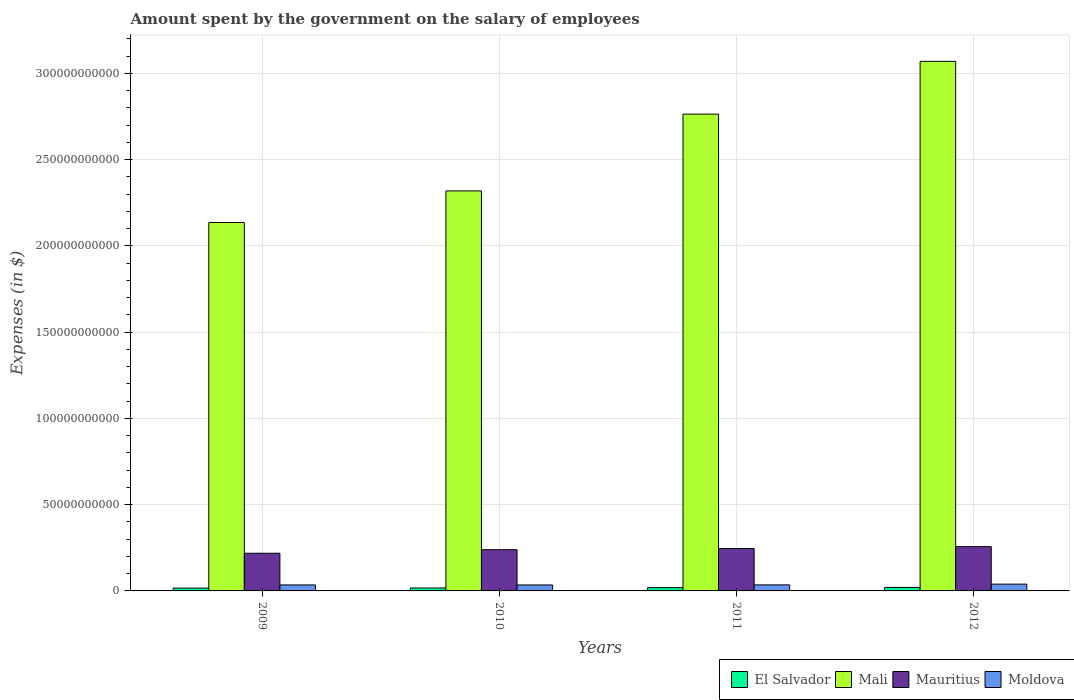How many groups of bars are there?
Keep it short and to the point. 4. Are the number of bars per tick equal to the number of legend labels?
Ensure brevity in your answer.  Yes. How many bars are there on the 1st tick from the left?
Offer a very short reply. 4. What is the label of the 4th group of bars from the left?
Your response must be concise. 2012. What is the amount spent on the salary of employees by the government in Moldova in 2011?
Ensure brevity in your answer.  3.50e+09. Across all years, what is the maximum amount spent on the salary of employees by the government in El Salvador?
Make the answer very short. 2.02e+09. Across all years, what is the minimum amount spent on the salary of employees by the government in El Salvador?
Your response must be concise. 1.64e+09. In which year was the amount spent on the salary of employees by the government in Moldova maximum?
Ensure brevity in your answer.  2012. In which year was the amount spent on the salary of employees by the government in El Salvador minimum?
Provide a short and direct response. 2009. What is the total amount spent on the salary of employees by the government in Mauritius in the graph?
Offer a very short reply. 9.60e+1. What is the difference between the amount spent on the salary of employees by the government in Mauritius in 2010 and that in 2012?
Give a very brief answer. -1.77e+09. What is the difference between the amount spent on the salary of employees by the government in El Salvador in 2010 and the amount spent on the salary of employees by the government in Moldova in 2012?
Offer a very short reply. -2.24e+09. What is the average amount spent on the salary of employees by the government in Moldova per year?
Provide a succinct answer. 3.59e+09. In the year 2011, what is the difference between the amount spent on the salary of employees by the government in El Salvador and amount spent on the salary of employees by the government in Mali?
Your response must be concise. -2.74e+11. In how many years, is the amount spent on the salary of employees by the government in Moldova greater than 300000000000 $?
Provide a short and direct response. 0. What is the ratio of the amount spent on the salary of employees by the government in Mauritius in 2009 to that in 2010?
Give a very brief answer. 0.91. What is the difference between the highest and the second highest amount spent on the salary of employees by the government in Mauritius?
Offer a terse response. 1.09e+09. What is the difference between the highest and the lowest amount spent on the salary of employees by the government in Mauritius?
Your answer should be compact. 3.83e+09. In how many years, is the amount spent on the salary of employees by the government in Moldova greater than the average amount spent on the salary of employees by the government in Moldova taken over all years?
Ensure brevity in your answer.  1. Is the sum of the amount spent on the salary of employees by the government in Mauritius in 2009 and 2010 greater than the maximum amount spent on the salary of employees by the government in El Salvador across all years?
Your response must be concise. Yes. What does the 2nd bar from the left in 2012 represents?
Your answer should be very brief. Mali. What does the 4th bar from the right in 2009 represents?
Provide a succinct answer. El Salvador. How many bars are there?
Offer a terse response. 16. How many years are there in the graph?
Offer a terse response. 4. Does the graph contain grids?
Offer a terse response. Yes. How many legend labels are there?
Your response must be concise. 4. What is the title of the graph?
Offer a very short reply. Amount spent by the government on the salary of employees. What is the label or title of the Y-axis?
Give a very brief answer. Expenses (in $). What is the Expenses (in $) of El Salvador in 2009?
Provide a succinct answer. 1.64e+09. What is the Expenses (in $) of Mali in 2009?
Ensure brevity in your answer.  2.14e+11. What is the Expenses (in $) of Mauritius in 2009?
Provide a short and direct response. 2.18e+1. What is the Expenses (in $) of Moldova in 2009?
Provide a succinct answer. 3.47e+09. What is the Expenses (in $) in El Salvador in 2010?
Keep it short and to the point. 1.70e+09. What is the Expenses (in $) of Mali in 2010?
Keep it short and to the point. 2.32e+11. What is the Expenses (in $) in Mauritius in 2010?
Provide a short and direct response. 2.39e+1. What is the Expenses (in $) of Moldova in 2010?
Offer a terse response. 3.46e+09. What is the Expenses (in $) in El Salvador in 2011?
Offer a terse response. 1.90e+09. What is the Expenses (in $) in Mali in 2011?
Give a very brief answer. 2.76e+11. What is the Expenses (in $) in Mauritius in 2011?
Offer a very short reply. 2.46e+1. What is the Expenses (in $) in Moldova in 2011?
Offer a terse response. 3.50e+09. What is the Expenses (in $) in El Salvador in 2012?
Your answer should be compact. 2.02e+09. What is the Expenses (in $) in Mali in 2012?
Make the answer very short. 3.07e+11. What is the Expenses (in $) in Mauritius in 2012?
Your response must be concise. 2.57e+1. What is the Expenses (in $) in Moldova in 2012?
Your answer should be very brief. 3.94e+09. Across all years, what is the maximum Expenses (in $) of El Salvador?
Ensure brevity in your answer.  2.02e+09. Across all years, what is the maximum Expenses (in $) in Mali?
Make the answer very short. 3.07e+11. Across all years, what is the maximum Expenses (in $) in Mauritius?
Give a very brief answer. 2.57e+1. Across all years, what is the maximum Expenses (in $) in Moldova?
Your answer should be very brief. 3.94e+09. Across all years, what is the minimum Expenses (in $) of El Salvador?
Keep it short and to the point. 1.64e+09. Across all years, what is the minimum Expenses (in $) in Mali?
Give a very brief answer. 2.14e+11. Across all years, what is the minimum Expenses (in $) of Mauritius?
Make the answer very short. 2.18e+1. Across all years, what is the minimum Expenses (in $) of Moldova?
Ensure brevity in your answer.  3.46e+09. What is the total Expenses (in $) of El Salvador in the graph?
Ensure brevity in your answer.  7.26e+09. What is the total Expenses (in $) of Mali in the graph?
Ensure brevity in your answer.  1.03e+12. What is the total Expenses (in $) in Mauritius in the graph?
Ensure brevity in your answer.  9.60e+1. What is the total Expenses (in $) in Moldova in the graph?
Provide a succinct answer. 1.44e+1. What is the difference between the Expenses (in $) of El Salvador in 2009 and that in 2010?
Your answer should be very brief. -6.58e+07. What is the difference between the Expenses (in $) in Mali in 2009 and that in 2010?
Your response must be concise. -1.83e+1. What is the difference between the Expenses (in $) of Mauritius in 2009 and that in 2010?
Offer a very short reply. -2.06e+09. What is the difference between the Expenses (in $) of Moldova in 2009 and that in 2010?
Make the answer very short. 1.01e+07. What is the difference between the Expenses (in $) in El Salvador in 2009 and that in 2011?
Provide a succinct answer. -2.57e+08. What is the difference between the Expenses (in $) of Mali in 2009 and that in 2011?
Your answer should be compact. -6.28e+1. What is the difference between the Expenses (in $) in Mauritius in 2009 and that in 2011?
Make the answer very short. -2.74e+09. What is the difference between the Expenses (in $) in Moldova in 2009 and that in 2011?
Provide a short and direct response. -3.28e+07. What is the difference between the Expenses (in $) in El Salvador in 2009 and that in 2012?
Offer a terse response. -3.85e+08. What is the difference between the Expenses (in $) of Mali in 2009 and that in 2012?
Give a very brief answer. -9.34e+1. What is the difference between the Expenses (in $) in Mauritius in 2009 and that in 2012?
Make the answer very short. -3.83e+09. What is the difference between the Expenses (in $) of Moldova in 2009 and that in 2012?
Keep it short and to the point. -4.75e+08. What is the difference between the Expenses (in $) in El Salvador in 2010 and that in 2011?
Your answer should be very brief. -1.91e+08. What is the difference between the Expenses (in $) of Mali in 2010 and that in 2011?
Ensure brevity in your answer.  -4.45e+1. What is the difference between the Expenses (in $) of Mauritius in 2010 and that in 2011?
Ensure brevity in your answer.  -6.81e+08. What is the difference between the Expenses (in $) in Moldova in 2010 and that in 2011?
Your answer should be very brief. -4.29e+07. What is the difference between the Expenses (in $) in El Salvador in 2010 and that in 2012?
Your answer should be compact. -3.19e+08. What is the difference between the Expenses (in $) in Mali in 2010 and that in 2012?
Provide a short and direct response. -7.51e+1. What is the difference between the Expenses (in $) in Mauritius in 2010 and that in 2012?
Provide a succinct answer. -1.77e+09. What is the difference between the Expenses (in $) in Moldova in 2010 and that in 2012?
Give a very brief answer. -4.85e+08. What is the difference between the Expenses (in $) of El Salvador in 2011 and that in 2012?
Give a very brief answer. -1.28e+08. What is the difference between the Expenses (in $) in Mali in 2011 and that in 2012?
Make the answer very short. -3.06e+1. What is the difference between the Expenses (in $) in Mauritius in 2011 and that in 2012?
Your answer should be compact. -1.09e+09. What is the difference between the Expenses (in $) in Moldova in 2011 and that in 2012?
Provide a short and direct response. -4.42e+08. What is the difference between the Expenses (in $) of El Salvador in 2009 and the Expenses (in $) of Mali in 2010?
Your response must be concise. -2.30e+11. What is the difference between the Expenses (in $) of El Salvador in 2009 and the Expenses (in $) of Mauritius in 2010?
Make the answer very short. -2.23e+1. What is the difference between the Expenses (in $) of El Salvador in 2009 and the Expenses (in $) of Moldova in 2010?
Give a very brief answer. -1.82e+09. What is the difference between the Expenses (in $) in Mali in 2009 and the Expenses (in $) in Mauritius in 2010?
Your answer should be compact. 1.90e+11. What is the difference between the Expenses (in $) of Mali in 2009 and the Expenses (in $) of Moldova in 2010?
Make the answer very short. 2.10e+11. What is the difference between the Expenses (in $) in Mauritius in 2009 and the Expenses (in $) in Moldova in 2010?
Your response must be concise. 1.84e+1. What is the difference between the Expenses (in $) of El Salvador in 2009 and the Expenses (in $) of Mali in 2011?
Ensure brevity in your answer.  -2.75e+11. What is the difference between the Expenses (in $) in El Salvador in 2009 and the Expenses (in $) in Mauritius in 2011?
Provide a short and direct response. -2.29e+1. What is the difference between the Expenses (in $) of El Salvador in 2009 and the Expenses (in $) of Moldova in 2011?
Give a very brief answer. -1.86e+09. What is the difference between the Expenses (in $) in Mali in 2009 and the Expenses (in $) in Mauritius in 2011?
Keep it short and to the point. 1.89e+11. What is the difference between the Expenses (in $) of Mali in 2009 and the Expenses (in $) of Moldova in 2011?
Your answer should be very brief. 2.10e+11. What is the difference between the Expenses (in $) of Mauritius in 2009 and the Expenses (in $) of Moldova in 2011?
Provide a short and direct response. 1.83e+1. What is the difference between the Expenses (in $) of El Salvador in 2009 and the Expenses (in $) of Mali in 2012?
Keep it short and to the point. -3.05e+11. What is the difference between the Expenses (in $) in El Salvador in 2009 and the Expenses (in $) in Mauritius in 2012?
Ensure brevity in your answer.  -2.40e+1. What is the difference between the Expenses (in $) in El Salvador in 2009 and the Expenses (in $) in Moldova in 2012?
Make the answer very short. -2.30e+09. What is the difference between the Expenses (in $) of Mali in 2009 and the Expenses (in $) of Mauritius in 2012?
Offer a very short reply. 1.88e+11. What is the difference between the Expenses (in $) of Mali in 2009 and the Expenses (in $) of Moldova in 2012?
Provide a succinct answer. 2.10e+11. What is the difference between the Expenses (in $) in Mauritius in 2009 and the Expenses (in $) in Moldova in 2012?
Ensure brevity in your answer.  1.79e+1. What is the difference between the Expenses (in $) of El Salvador in 2010 and the Expenses (in $) of Mali in 2011?
Your response must be concise. -2.75e+11. What is the difference between the Expenses (in $) in El Salvador in 2010 and the Expenses (in $) in Mauritius in 2011?
Ensure brevity in your answer.  -2.29e+1. What is the difference between the Expenses (in $) of El Salvador in 2010 and the Expenses (in $) of Moldova in 2011?
Offer a terse response. -1.80e+09. What is the difference between the Expenses (in $) of Mali in 2010 and the Expenses (in $) of Mauritius in 2011?
Offer a very short reply. 2.07e+11. What is the difference between the Expenses (in $) of Mali in 2010 and the Expenses (in $) of Moldova in 2011?
Offer a very short reply. 2.28e+11. What is the difference between the Expenses (in $) in Mauritius in 2010 and the Expenses (in $) in Moldova in 2011?
Make the answer very short. 2.04e+1. What is the difference between the Expenses (in $) in El Salvador in 2010 and the Expenses (in $) in Mali in 2012?
Your answer should be very brief. -3.05e+11. What is the difference between the Expenses (in $) of El Salvador in 2010 and the Expenses (in $) of Mauritius in 2012?
Provide a succinct answer. -2.40e+1. What is the difference between the Expenses (in $) in El Salvador in 2010 and the Expenses (in $) in Moldova in 2012?
Your response must be concise. -2.24e+09. What is the difference between the Expenses (in $) of Mali in 2010 and the Expenses (in $) of Mauritius in 2012?
Your response must be concise. 2.06e+11. What is the difference between the Expenses (in $) of Mali in 2010 and the Expenses (in $) of Moldova in 2012?
Your response must be concise. 2.28e+11. What is the difference between the Expenses (in $) of Mauritius in 2010 and the Expenses (in $) of Moldova in 2012?
Offer a very short reply. 1.99e+1. What is the difference between the Expenses (in $) in El Salvador in 2011 and the Expenses (in $) in Mali in 2012?
Your answer should be compact. -3.05e+11. What is the difference between the Expenses (in $) in El Salvador in 2011 and the Expenses (in $) in Mauritius in 2012?
Offer a terse response. -2.38e+1. What is the difference between the Expenses (in $) in El Salvador in 2011 and the Expenses (in $) in Moldova in 2012?
Give a very brief answer. -2.05e+09. What is the difference between the Expenses (in $) in Mali in 2011 and the Expenses (in $) in Mauritius in 2012?
Provide a succinct answer. 2.51e+11. What is the difference between the Expenses (in $) in Mali in 2011 and the Expenses (in $) in Moldova in 2012?
Your answer should be compact. 2.72e+11. What is the difference between the Expenses (in $) of Mauritius in 2011 and the Expenses (in $) of Moldova in 2012?
Make the answer very short. 2.06e+1. What is the average Expenses (in $) in El Salvador per year?
Your response must be concise. 1.82e+09. What is the average Expenses (in $) in Mali per year?
Ensure brevity in your answer.  2.57e+11. What is the average Expenses (in $) of Mauritius per year?
Keep it short and to the point. 2.40e+1. What is the average Expenses (in $) in Moldova per year?
Provide a short and direct response. 3.59e+09. In the year 2009, what is the difference between the Expenses (in $) in El Salvador and Expenses (in $) in Mali?
Your response must be concise. -2.12e+11. In the year 2009, what is the difference between the Expenses (in $) of El Salvador and Expenses (in $) of Mauritius?
Give a very brief answer. -2.02e+1. In the year 2009, what is the difference between the Expenses (in $) in El Salvador and Expenses (in $) in Moldova?
Make the answer very short. -1.83e+09. In the year 2009, what is the difference between the Expenses (in $) of Mali and Expenses (in $) of Mauritius?
Make the answer very short. 1.92e+11. In the year 2009, what is the difference between the Expenses (in $) of Mali and Expenses (in $) of Moldova?
Offer a terse response. 2.10e+11. In the year 2009, what is the difference between the Expenses (in $) of Mauritius and Expenses (in $) of Moldova?
Keep it short and to the point. 1.84e+1. In the year 2010, what is the difference between the Expenses (in $) in El Salvador and Expenses (in $) in Mali?
Your answer should be very brief. -2.30e+11. In the year 2010, what is the difference between the Expenses (in $) of El Salvador and Expenses (in $) of Mauritius?
Give a very brief answer. -2.22e+1. In the year 2010, what is the difference between the Expenses (in $) of El Salvador and Expenses (in $) of Moldova?
Your answer should be compact. -1.75e+09. In the year 2010, what is the difference between the Expenses (in $) of Mali and Expenses (in $) of Mauritius?
Your answer should be very brief. 2.08e+11. In the year 2010, what is the difference between the Expenses (in $) of Mali and Expenses (in $) of Moldova?
Offer a terse response. 2.28e+11. In the year 2010, what is the difference between the Expenses (in $) in Mauritius and Expenses (in $) in Moldova?
Provide a succinct answer. 2.04e+1. In the year 2011, what is the difference between the Expenses (in $) in El Salvador and Expenses (in $) in Mali?
Your answer should be very brief. -2.74e+11. In the year 2011, what is the difference between the Expenses (in $) in El Salvador and Expenses (in $) in Mauritius?
Make the answer very short. -2.27e+1. In the year 2011, what is the difference between the Expenses (in $) of El Salvador and Expenses (in $) of Moldova?
Offer a very short reply. -1.61e+09. In the year 2011, what is the difference between the Expenses (in $) in Mali and Expenses (in $) in Mauritius?
Provide a short and direct response. 2.52e+11. In the year 2011, what is the difference between the Expenses (in $) in Mali and Expenses (in $) in Moldova?
Keep it short and to the point. 2.73e+11. In the year 2011, what is the difference between the Expenses (in $) of Mauritius and Expenses (in $) of Moldova?
Provide a succinct answer. 2.11e+1. In the year 2012, what is the difference between the Expenses (in $) in El Salvador and Expenses (in $) in Mali?
Offer a terse response. -3.05e+11. In the year 2012, what is the difference between the Expenses (in $) in El Salvador and Expenses (in $) in Mauritius?
Provide a succinct answer. -2.36e+1. In the year 2012, what is the difference between the Expenses (in $) of El Salvador and Expenses (in $) of Moldova?
Your answer should be compact. -1.92e+09. In the year 2012, what is the difference between the Expenses (in $) of Mali and Expenses (in $) of Mauritius?
Ensure brevity in your answer.  2.81e+11. In the year 2012, what is the difference between the Expenses (in $) of Mali and Expenses (in $) of Moldova?
Offer a terse response. 3.03e+11. In the year 2012, what is the difference between the Expenses (in $) in Mauritius and Expenses (in $) in Moldova?
Your response must be concise. 2.17e+1. What is the ratio of the Expenses (in $) of El Salvador in 2009 to that in 2010?
Keep it short and to the point. 0.96. What is the ratio of the Expenses (in $) in Mali in 2009 to that in 2010?
Provide a short and direct response. 0.92. What is the ratio of the Expenses (in $) in Mauritius in 2009 to that in 2010?
Make the answer very short. 0.91. What is the ratio of the Expenses (in $) in Moldova in 2009 to that in 2010?
Make the answer very short. 1. What is the ratio of the Expenses (in $) of El Salvador in 2009 to that in 2011?
Keep it short and to the point. 0.86. What is the ratio of the Expenses (in $) of Mali in 2009 to that in 2011?
Provide a short and direct response. 0.77. What is the ratio of the Expenses (in $) in Mauritius in 2009 to that in 2011?
Offer a terse response. 0.89. What is the ratio of the Expenses (in $) in Moldova in 2009 to that in 2011?
Your answer should be very brief. 0.99. What is the ratio of the Expenses (in $) of El Salvador in 2009 to that in 2012?
Make the answer very short. 0.81. What is the ratio of the Expenses (in $) of Mali in 2009 to that in 2012?
Give a very brief answer. 0.7. What is the ratio of the Expenses (in $) in Mauritius in 2009 to that in 2012?
Provide a short and direct response. 0.85. What is the ratio of the Expenses (in $) in Moldova in 2009 to that in 2012?
Ensure brevity in your answer.  0.88. What is the ratio of the Expenses (in $) in El Salvador in 2010 to that in 2011?
Provide a succinct answer. 0.9. What is the ratio of the Expenses (in $) of Mali in 2010 to that in 2011?
Make the answer very short. 0.84. What is the ratio of the Expenses (in $) in Mauritius in 2010 to that in 2011?
Give a very brief answer. 0.97. What is the ratio of the Expenses (in $) in Moldova in 2010 to that in 2011?
Keep it short and to the point. 0.99. What is the ratio of the Expenses (in $) in El Salvador in 2010 to that in 2012?
Your answer should be compact. 0.84. What is the ratio of the Expenses (in $) in Mali in 2010 to that in 2012?
Ensure brevity in your answer.  0.76. What is the ratio of the Expenses (in $) in Mauritius in 2010 to that in 2012?
Your response must be concise. 0.93. What is the ratio of the Expenses (in $) in Moldova in 2010 to that in 2012?
Your response must be concise. 0.88. What is the ratio of the Expenses (in $) in El Salvador in 2011 to that in 2012?
Your response must be concise. 0.94. What is the ratio of the Expenses (in $) of Mali in 2011 to that in 2012?
Provide a succinct answer. 0.9. What is the ratio of the Expenses (in $) of Mauritius in 2011 to that in 2012?
Your answer should be compact. 0.96. What is the ratio of the Expenses (in $) of Moldova in 2011 to that in 2012?
Your answer should be very brief. 0.89. What is the difference between the highest and the second highest Expenses (in $) in El Salvador?
Ensure brevity in your answer.  1.28e+08. What is the difference between the highest and the second highest Expenses (in $) of Mali?
Your answer should be very brief. 3.06e+1. What is the difference between the highest and the second highest Expenses (in $) of Mauritius?
Your answer should be very brief. 1.09e+09. What is the difference between the highest and the second highest Expenses (in $) of Moldova?
Your answer should be very brief. 4.42e+08. What is the difference between the highest and the lowest Expenses (in $) of El Salvador?
Ensure brevity in your answer.  3.85e+08. What is the difference between the highest and the lowest Expenses (in $) in Mali?
Ensure brevity in your answer.  9.34e+1. What is the difference between the highest and the lowest Expenses (in $) in Mauritius?
Your answer should be compact. 3.83e+09. What is the difference between the highest and the lowest Expenses (in $) in Moldova?
Your response must be concise. 4.85e+08. 